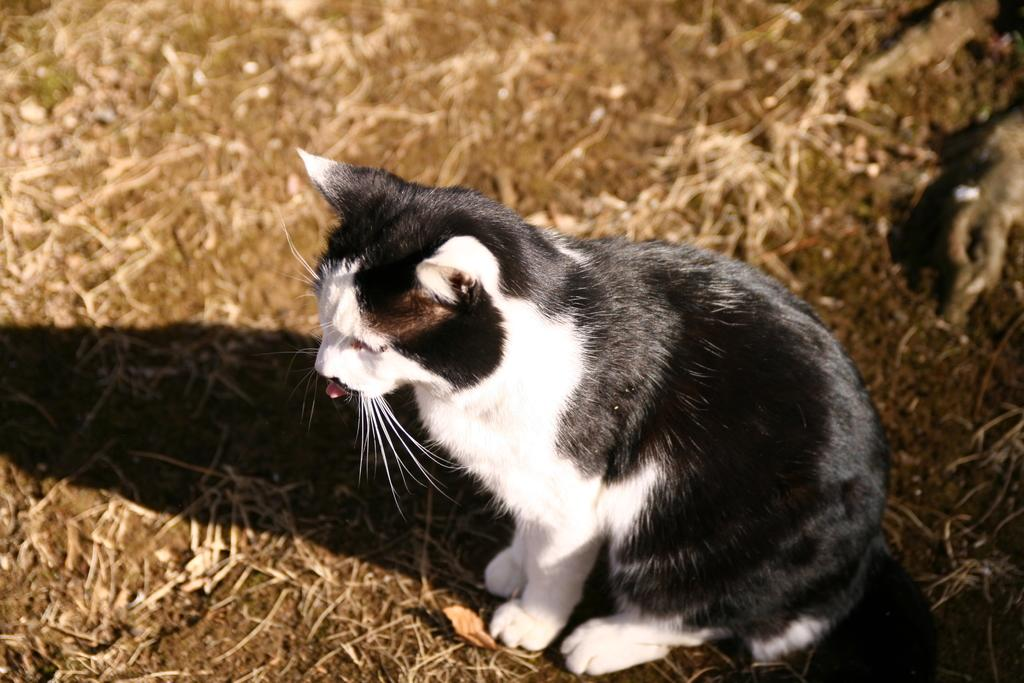What type of animal is in the picture? There is a cat in the picture. Can you describe the color of the cat? The cat is black and white in color. Where is the cat located in the picture? The cat is on the ground. What type of punishment is the cat receiving in the image? There is no punishment being administered to the cat in the image; it is simply on the ground. 